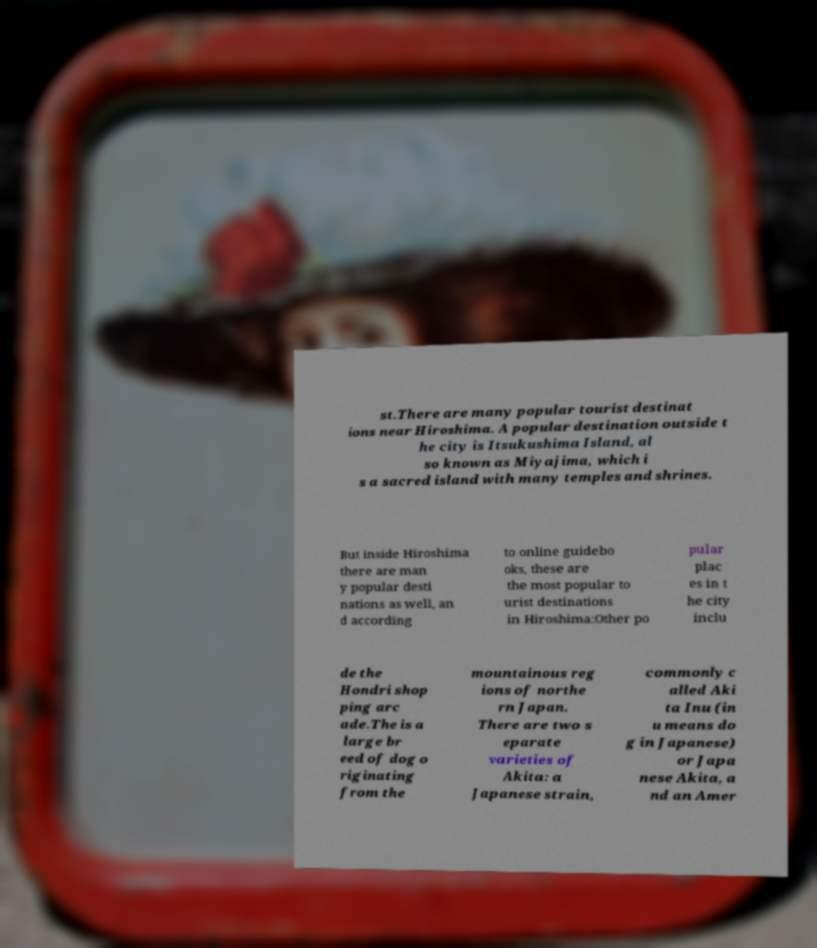Please read and relay the text visible in this image. What does it say? st.There are many popular tourist destinat ions near Hiroshima. A popular destination outside t he city is Itsukushima Island, al so known as Miyajima, which i s a sacred island with many temples and shrines. But inside Hiroshima there are man y popular desti nations as well, an d according to online guidebo oks, these are the most popular to urist destinations in Hiroshima:Other po pular plac es in t he city inclu de the Hondri shop ping arc ade.The is a large br eed of dog o riginating from the mountainous reg ions of northe rn Japan. There are two s eparate varieties of Akita: a Japanese strain, commonly c alled Aki ta Inu (in u means do g in Japanese) or Japa nese Akita, a nd an Amer 